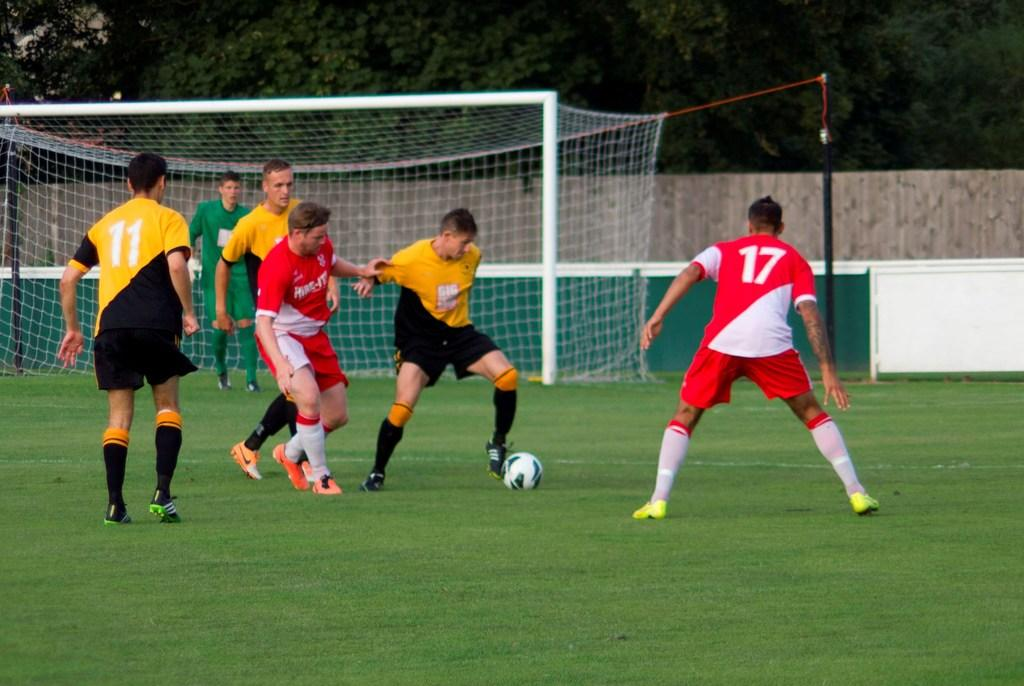<image>
Summarize the visual content of the image. Soccer players on a field, # 17 is shown in red and # 11 in yellow. 